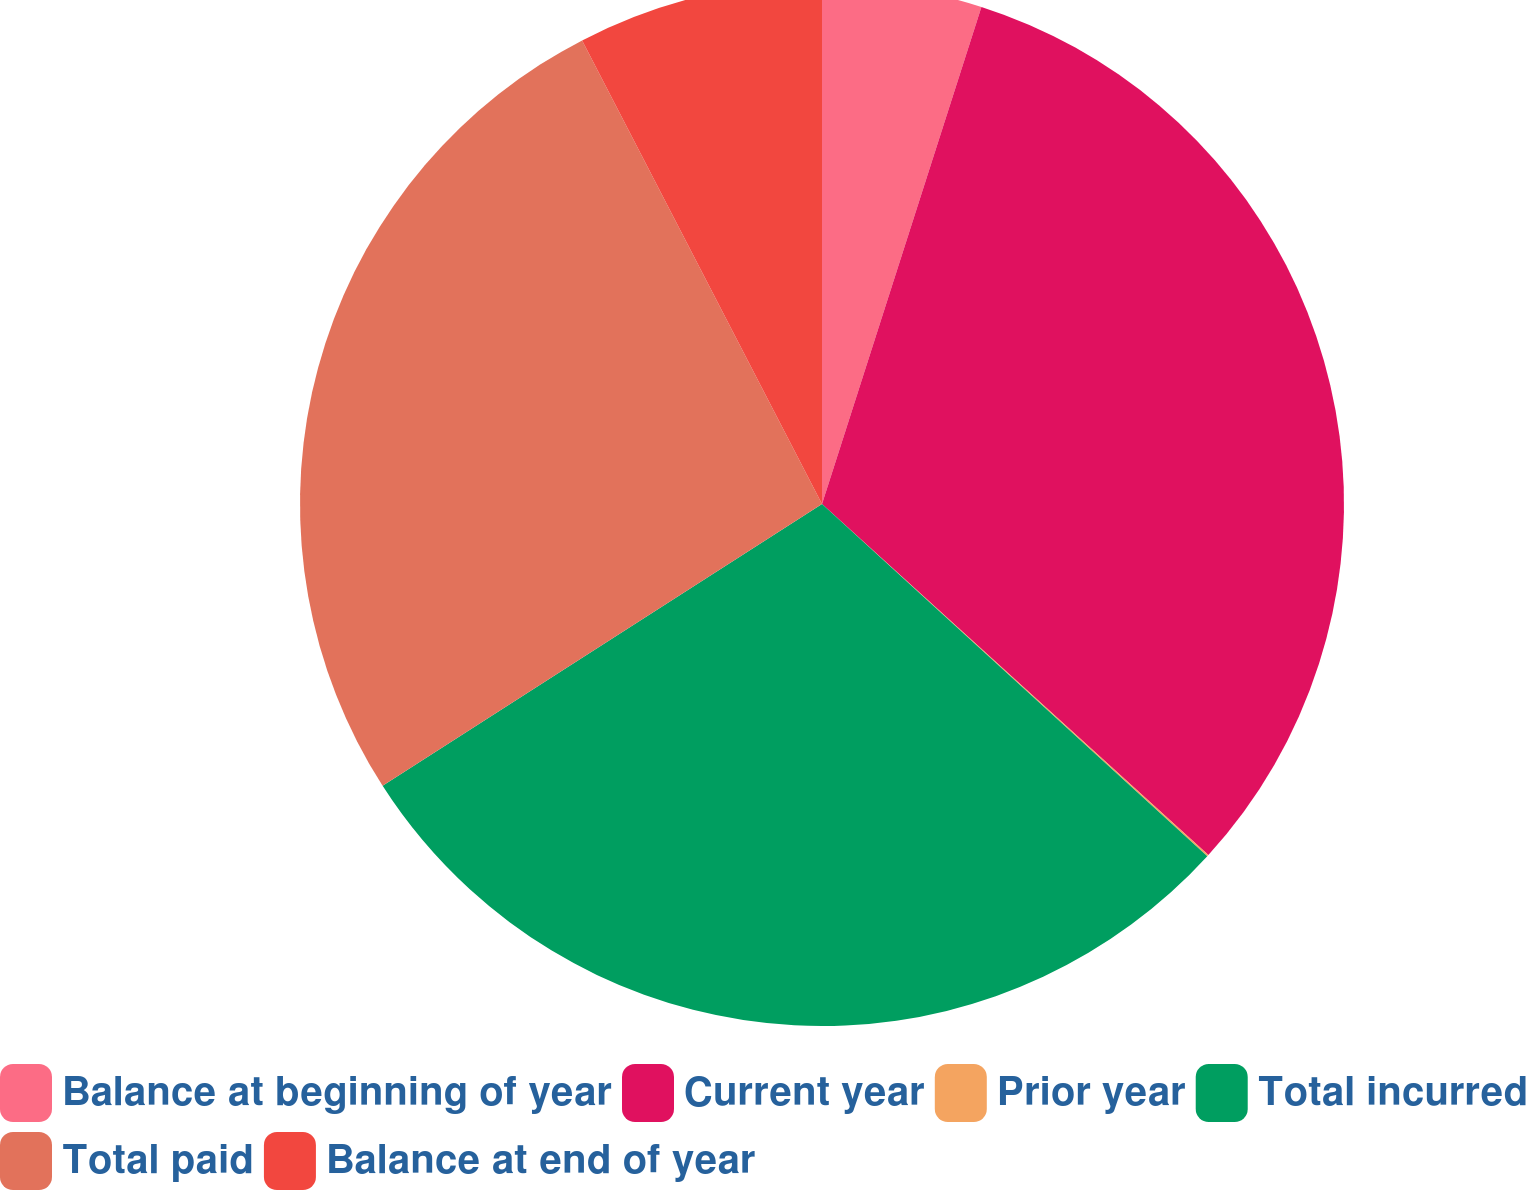Convert chart. <chart><loc_0><loc_0><loc_500><loc_500><pie_chart><fcel>Balance at beginning of year<fcel>Current year<fcel>Prior year<fcel>Total incurred<fcel>Total paid<fcel>Balance at end of year<nl><fcel>4.94%<fcel>31.8%<fcel>0.05%<fcel>29.14%<fcel>26.48%<fcel>7.6%<nl></chart> 